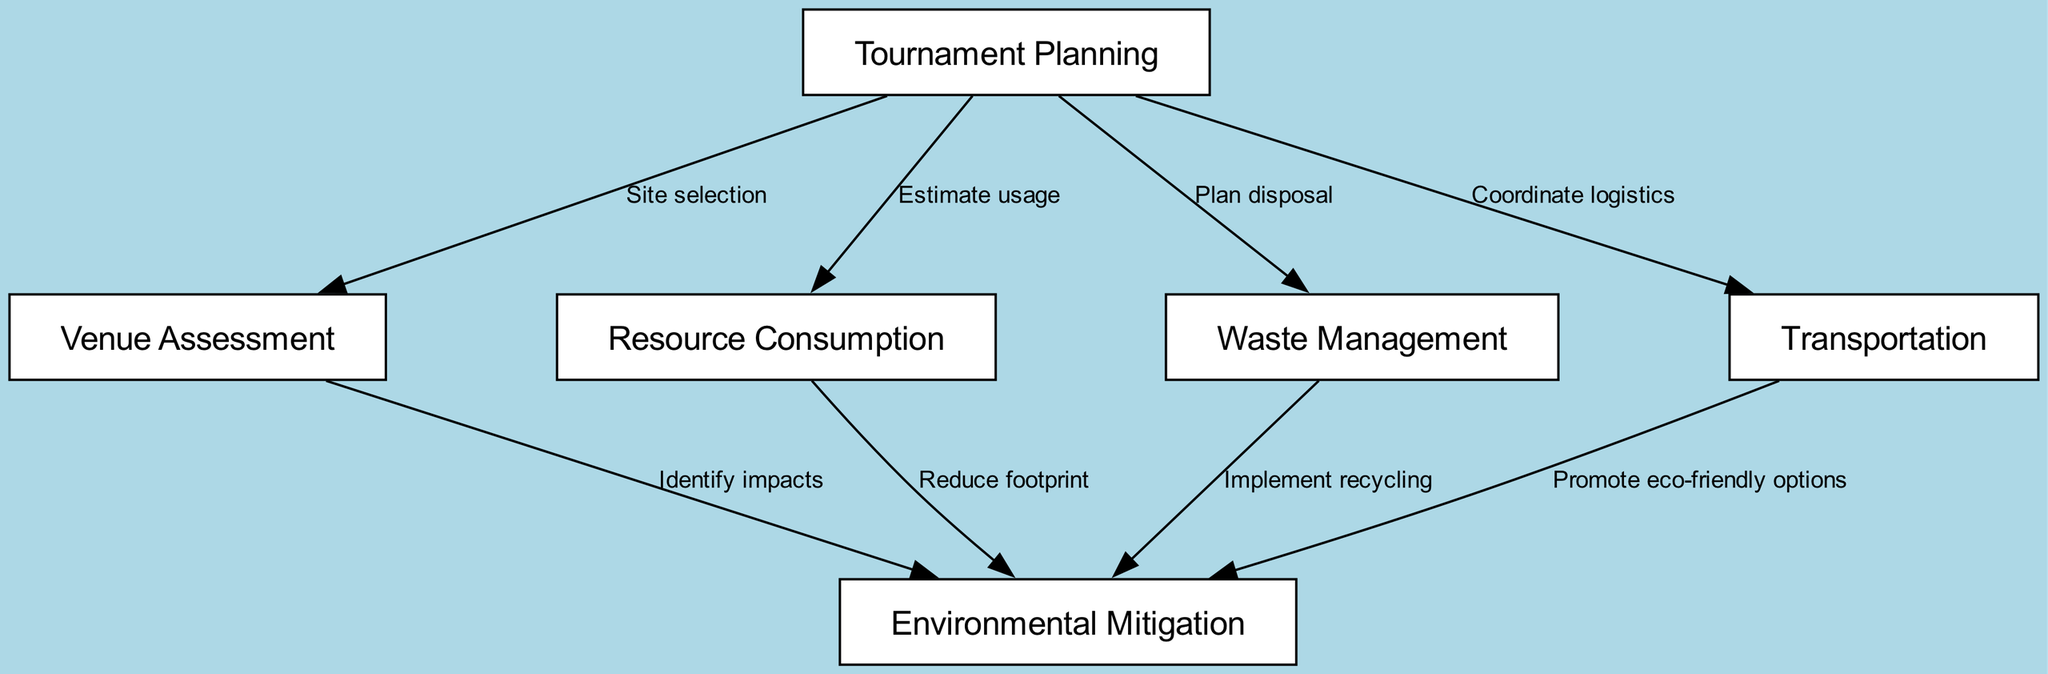What is the first step in the environmental impact assessment? The first step is "Tournament Planning," which is the initial node from which all the other nodes connect. It serves as the foundational stage of the assessment process.
Answer: Tournament Planning How many nodes are present in the diagram? The diagram contains six nodes, which are uniquely identified and contribute to different aspects of the environmental impact assessment.
Answer: Six What does "Venue Assessment" lead to? "Venue Assessment" leads to "Environmental Mitigation" through the edge labeled "Identify impacts," indicating that assessing the venue is critical to identify potential environmental impacts.
Answer: Environmental Mitigation Which node is directly connected to "Waste Management"? "Waste Management" connects to "Environmental Mitigation" through the edge labeled "Implement recycling," indicating that proper waste management is important for mitigating environmental effects.
Answer: Environmental Mitigation What type of logistical coordination is involved in the tournament planning? The tournament planning involves "Coordinate logistics," indicating that transportation and related logistics are managed in the planning phase to enhance sustainability.
Answer: Coordinate logistics What are the implications of "Resource Consumption" on environmental strategies? "Resource Consumption" leads to "Environmental Mitigation," specifically contributing to efforts to "Reduce footprint," highlighting the relationship between resource use and sustainability strategies.
Answer: Reduce footprint What are the two elements linked to "Transportation" in the context of environmental assessment? "Transportation" connects to "Environmental Mitigation," with an emphasis on promoting eco-friendly options, showing how transportation methods can influence environmental strategies.
Answer: Environmental Mitigation, Promote eco-friendly options How many edges are present in the diagram? The diagram has eight edges, which represent the various relationships and processes between the nodes in the environmental impact assessment flow.
Answer: Eight 